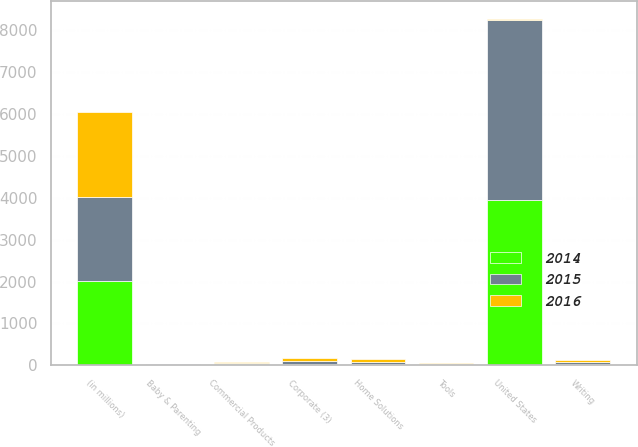Convert chart. <chart><loc_0><loc_0><loc_500><loc_500><stacked_bar_chart><ecel><fcel>Writing<fcel>Home Solutions<fcel>Tools<fcel>Commercial Products<fcel>Baby & Parenting<fcel>Corporate (3)<fcel>(in millions)<fcel>United States<nl><fcel>2016<fcel>61.8<fcel>59.8<fcel>19.1<fcel>22.9<fcel>12.5<fcel>72.6<fcel>2016<fcel>39.5<nl><fcel>2015<fcel>39.5<fcel>47.6<fcel>19.2<fcel>31.1<fcel>14.1<fcel>58.7<fcel>2015<fcel>4291.8<nl><fcel>2014<fcel>34.3<fcel>31.1<fcel>18.4<fcel>27.6<fcel>8.7<fcel>40.1<fcel>2014<fcel>3945.1<nl></chart> 